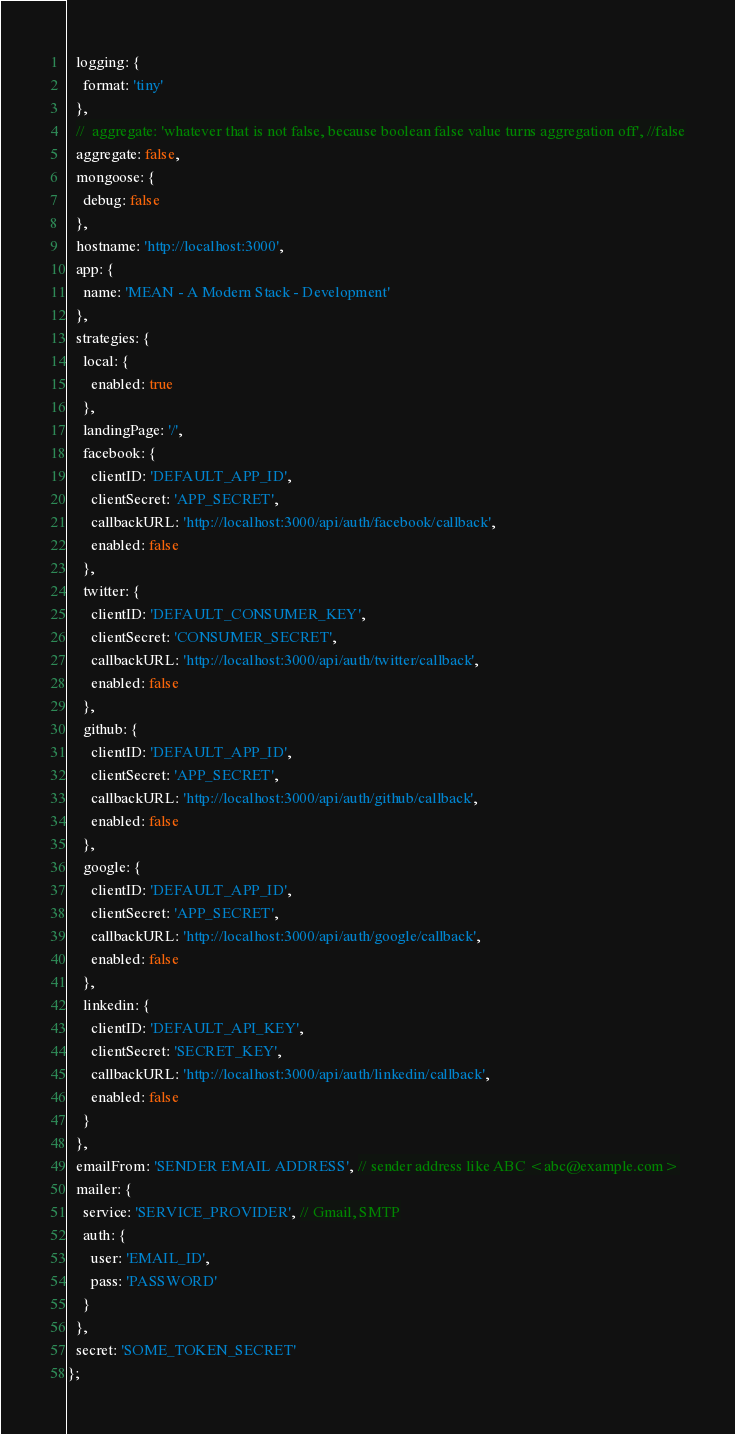<code> <loc_0><loc_0><loc_500><loc_500><_JavaScript_>  logging: {
    format: 'tiny'
  },
  //  aggregate: 'whatever that is not false, because boolean false value turns aggregation off', //false
  aggregate: false,
  mongoose: {
    debug: false
  },
  hostname: 'http://localhost:3000',
  app: {
    name: 'MEAN - A Modern Stack - Development'
  },
  strategies: {
    local: {
      enabled: true
    },
    landingPage: '/',
    facebook: {
      clientID: 'DEFAULT_APP_ID',
      clientSecret: 'APP_SECRET',
      callbackURL: 'http://localhost:3000/api/auth/facebook/callback',
      enabled: false
    },
    twitter: {
      clientID: 'DEFAULT_CONSUMER_KEY',
      clientSecret: 'CONSUMER_SECRET',
      callbackURL: 'http://localhost:3000/api/auth/twitter/callback',
      enabled: false
    },
    github: {
      clientID: 'DEFAULT_APP_ID',
      clientSecret: 'APP_SECRET',
      callbackURL: 'http://localhost:3000/api/auth/github/callback',
      enabled: false
    },
    google: {
      clientID: 'DEFAULT_APP_ID',
      clientSecret: 'APP_SECRET',
      callbackURL: 'http://localhost:3000/api/auth/google/callback',
      enabled: false
    },
    linkedin: {
      clientID: 'DEFAULT_API_KEY',
      clientSecret: 'SECRET_KEY',
      callbackURL: 'http://localhost:3000/api/auth/linkedin/callback',
      enabled: false
    }
  },
  emailFrom: 'SENDER EMAIL ADDRESS', // sender address like ABC <abc@example.com>
  mailer: {
    service: 'SERVICE_PROVIDER', // Gmail, SMTP
    auth: {
      user: 'EMAIL_ID',
      pass: 'PASSWORD'
    }
  }, 
  secret: 'SOME_TOKEN_SECRET'
};
</code> 